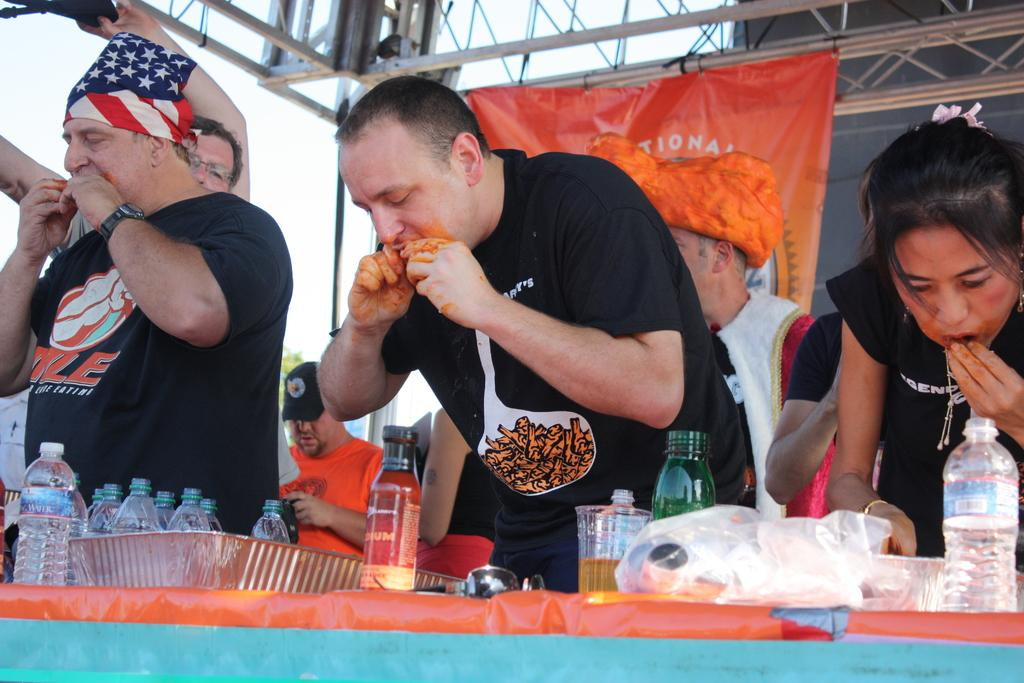What are the people in the image doing? The people in the image are eating. What types of containers can be seen in the image? There are bottles and glasses in the image. What is on the surface in the image? There are objects on a surface in the image. What type of structure is present in the image? There is metal framing in the image. What type of decoration is present in the image? There are banners in the image. What type of fowl can be seen in the image? There is no fowl present in the image. What type of bucket is being used by the people in the image? There is no bucket present in the image. 